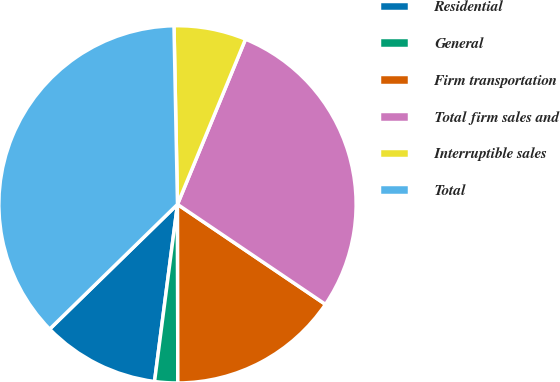<chart> <loc_0><loc_0><loc_500><loc_500><pie_chart><fcel>Residential<fcel>General<fcel>Firm transportation<fcel>Total firm sales and<fcel>Interruptible sales<fcel>Total<nl><fcel>10.64%<fcel>2.08%<fcel>15.51%<fcel>28.24%<fcel>6.53%<fcel>36.99%<nl></chart> 